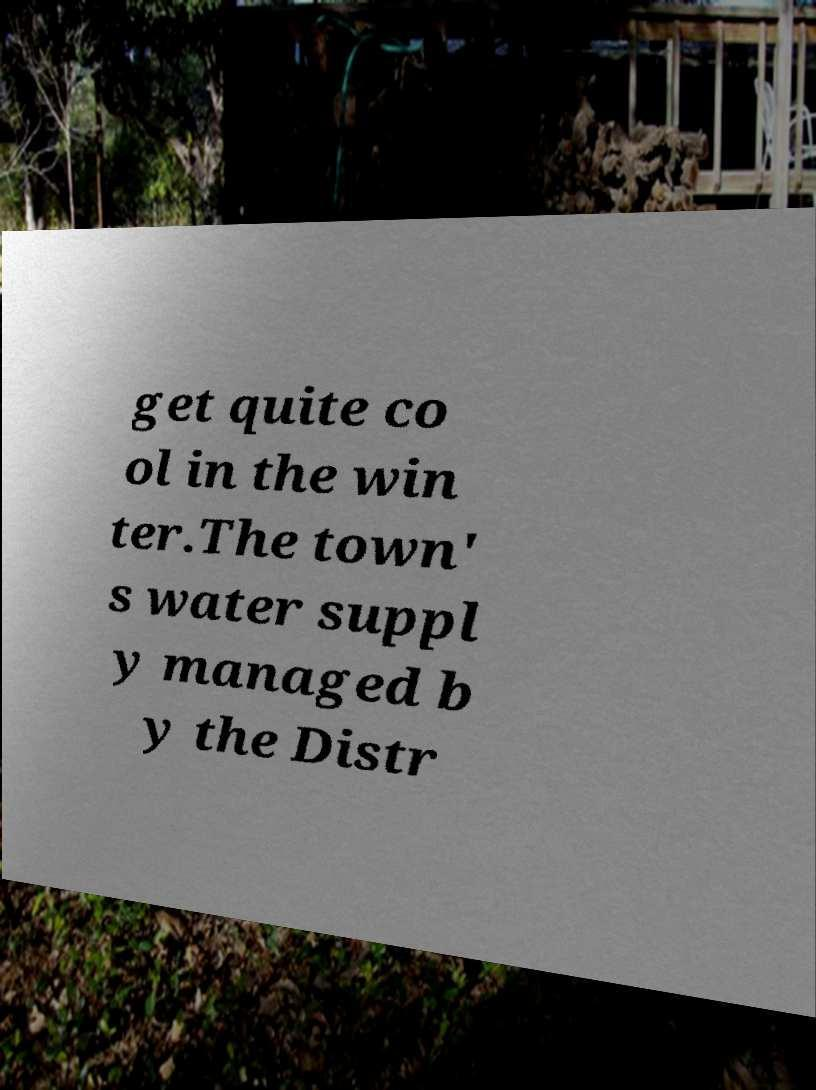Please identify and transcribe the text found in this image. get quite co ol in the win ter.The town' s water suppl y managed b y the Distr 